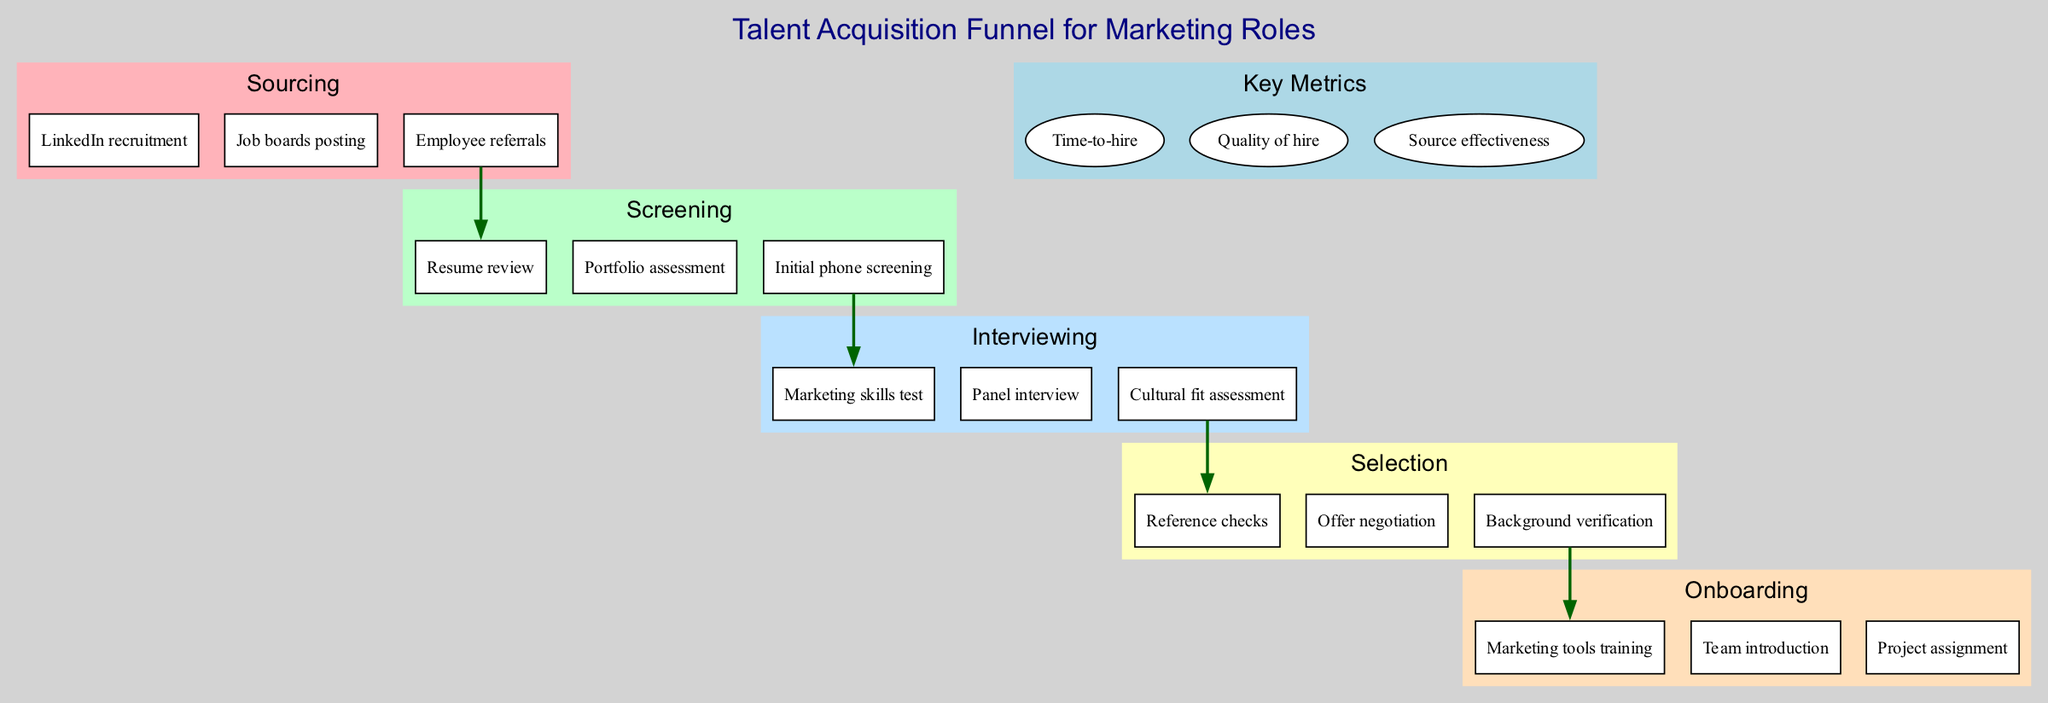What are the three key metrics depicted in the diagram? The diagram lists three key metrics at the bottom: "Time-to-hire", "Quality of hire", and "Source effectiveness".
Answer: Time-to-hire, Quality of hire, Source effectiveness Which stage includes "Resume review" as an activity? "Resume review" is listed under the "Screening" stage, which is the second stage in the funnel.
Answer: Screening How many activities are listed under the "Interviewing" stage? The "Interviewing" stage contains three activities: "Marketing skills test", "Panel interview", and "Cultural fit assessment". Thus, there are three activities.
Answer: 3 What is the first activity in the "Onboarding" stage? The first activity listed under the "Onboarding" stage is "Marketing tools training", which is the top activity in that section.
Answer: Marketing tools training Which stage precedes the "Selection" stage? The "Interviewing" stage is directly before the "Selection" stage in the flow of the talent acquisition funnel.
Answer: Interviewing How many total stages are there in the talent acquisition funnel? The diagram outlines five distinct stages, including Sourcing, Screening, Interviewing, Selection, and Onboarding.
Answer: 5 What is the color representing the "Screening" stage? The "Screening" stage is represented by the color #BAFFC9, which is a soft green shade in the diagram.
Answer: #BAFFC9 What activity is located last in the "Selection" stage? The last activity listed in the "Selection" stage is "Background verification", which is the third activity in that section.
Answer: Background verification What is the shape used for the activities in the diagram? The activities within each stage are represented by a box shape, as indicated in the visual design of the diagram.
Answer: box 